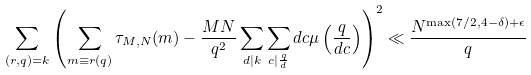Convert formula to latex. <formula><loc_0><loc_0><loc_500><loc_500>\sum _ { ( r , q ) = k } \left ( \sum _ { m \equiv r ( q ) } \tau _ { M , N } ( m ) - \frac { M N } { q ^ { 2 } } \sum _ { d | k } \sum _ { c | \frac { q } { d } } d c \mu \left ( \frac { q } { d c } \right ) \right ) ^ { 2 } \ll \frac { N ^ { \max ( 7 / 2 , 4 - \delta ) + \epsilon } } { q }</formula> 